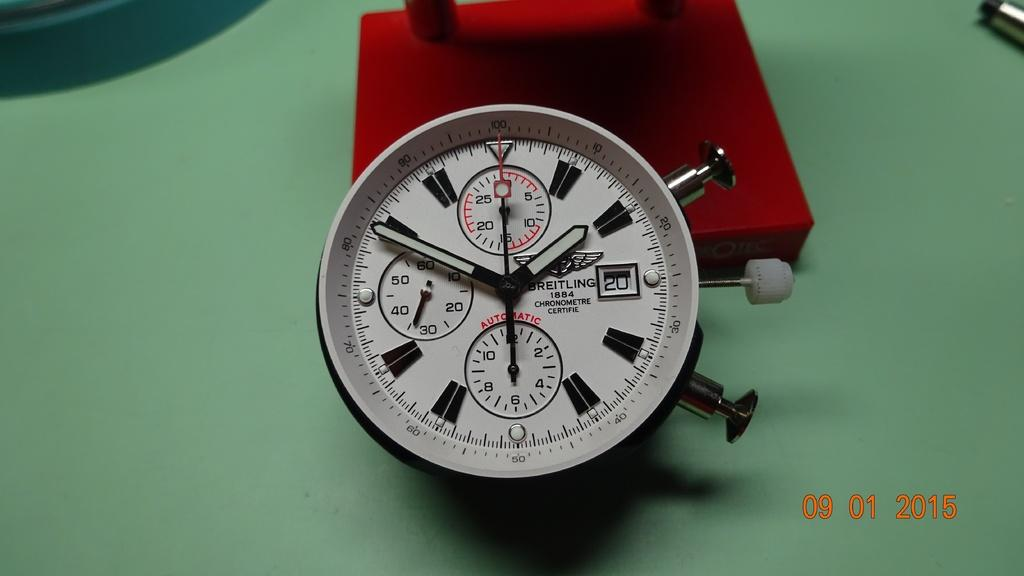<image>
Present a compact description of the photo's key features. A stop watch has the number 20 on it and is sitting on a green table. 